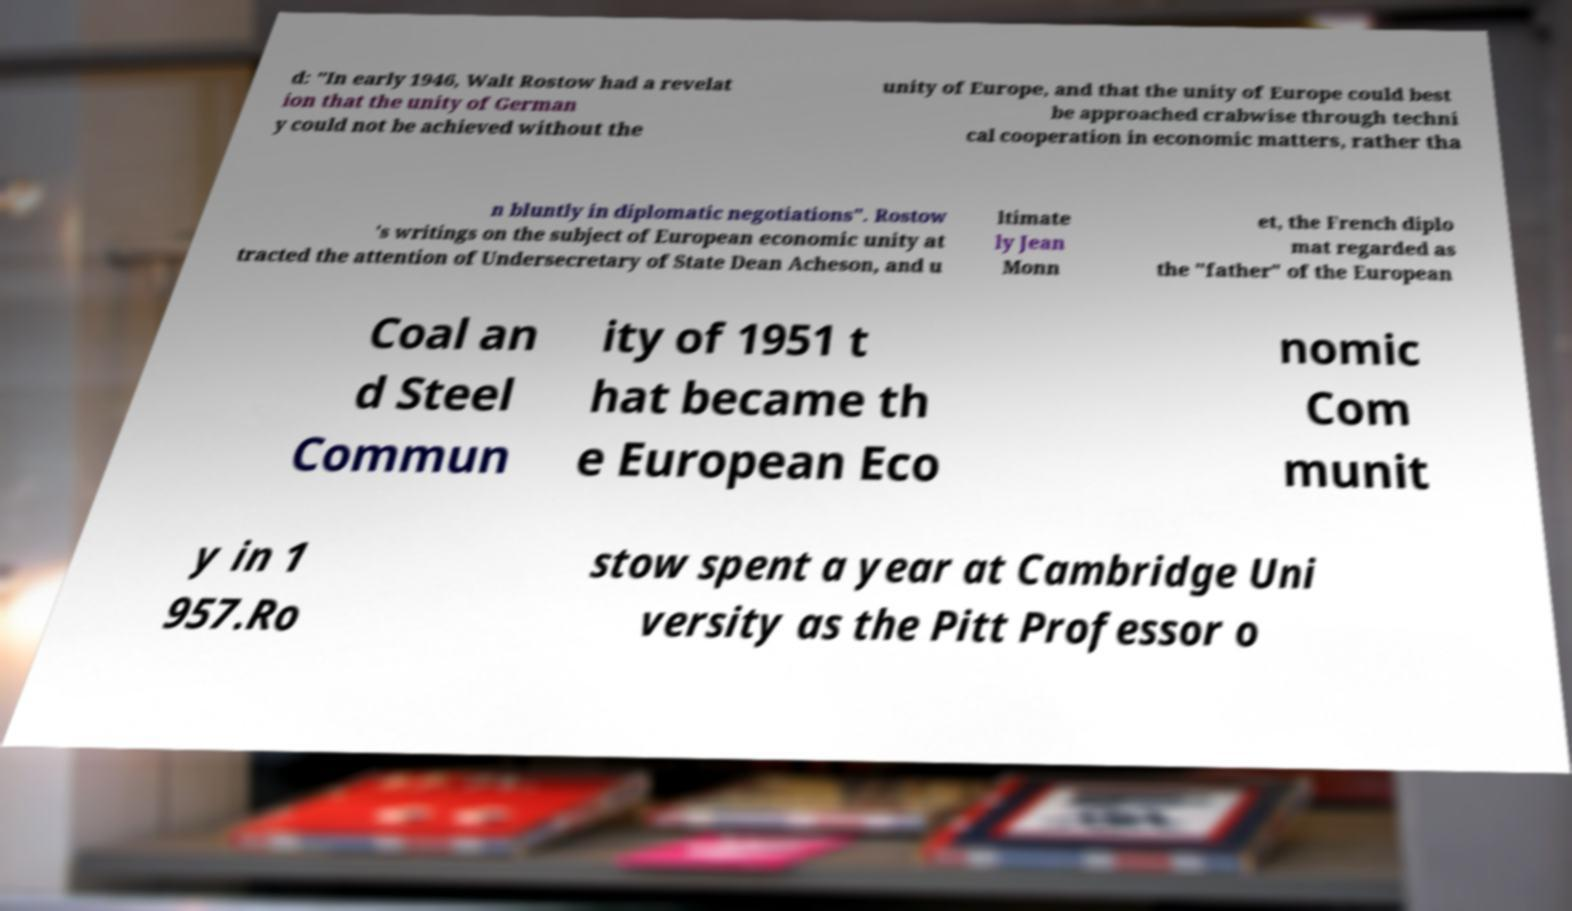What messages or text are displayed in this image? I need them in a readable, typed format. d: "In early 1946, Walt Rostow had a revelat ion that the unity of German y could not be achieved without the unity of Europe, and that the unity of Europe could best be approached crabwise through techni cal cooperation in economic matters, rather tha n bluntly in diplomatic negotiations". Rostow 's writings on the subject of European economic unity at tracted the attention of Undersecretary of State Dean Acheson, and u ltimate ly Jean Monn et, the French diplo mat regarded as the "father" of the European Coal an d Steel Commun ity of 1951 t hat became th e European Eco nomic Com munit y in 1 957.Ro stow spent a year at Cambridge Uni versity as the Pitt Professor o 